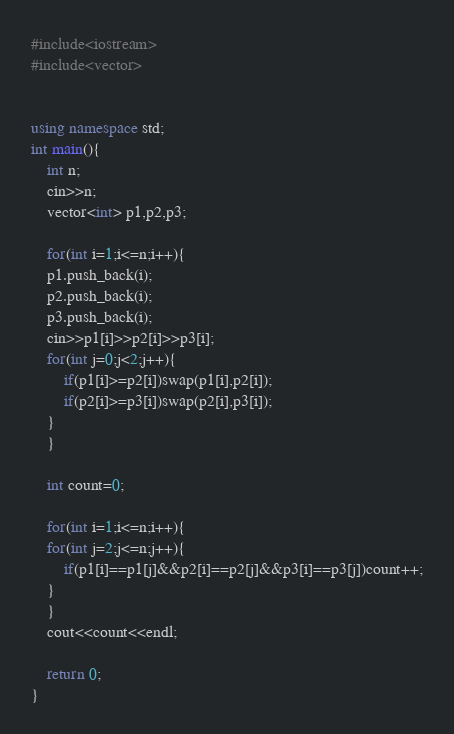<code> <loc_0><loc_0><loc_500><loc_500><_C++_>#include<iostream>
#include<vector>


using namespace std;
int main(){
	int n;
	cin>>n;
	vector<int> p1,p2,p3;
	
	for(int i=1;i<=n;i++){
	p1.push_back(i);
	p2.push_back(i);
	p3.push_back(i);
	cin>>p1[i]>>p2[i]>>p3[i];
	for(int j=0;j<2;j++){
		if(p1[i]>=p2[i])swap(p1[i],p2[i]);
		if(p2[i]>=p3[i])swap(p2[i],p3[i]);
	}
	}
	
	int count=0;
	
	for(int i=1;i<=n;i++){
	for(int j=2;j<=n;j++){
		if(p1[i]==p1[j]&&p2[i]==p2[j]&&p3[i]==p3[j])count++;
	}
	}
	cout<<count<<endl;
	
	return 0;
}
</code> 